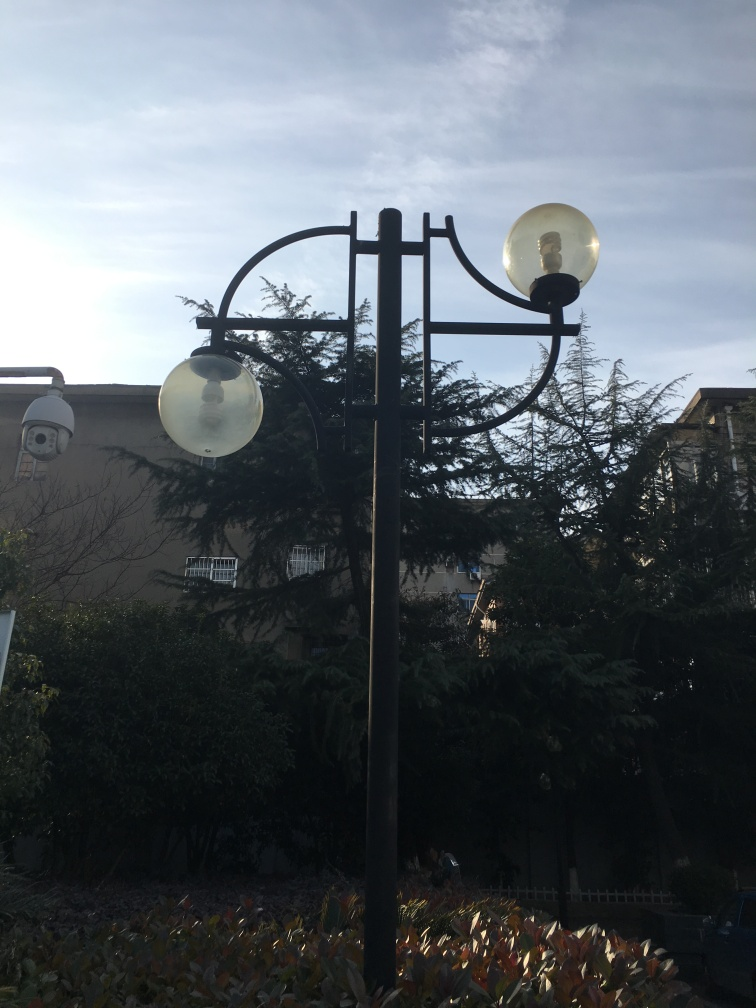What time of day does this image appear to have been taken? The image seems to have been captured during the early morning hours. This can be inferred from the soft and diffused lighting, as well as the absence of strong shadows which are often present during midday. Additionally, the lamps being on suggests it's either dawn or dusk, and given the brightness in the sky, early morning is more likely. 